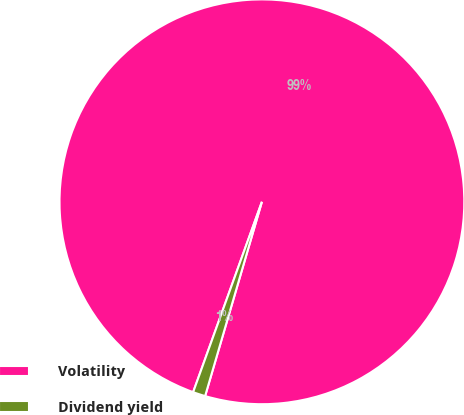Convert chart to OTSL. <chart><loc_0><loc_0><loc_500><loc_500><pie_chart><fcel>Volatility<fcel>Dividend yield<nl><fcel>99.01%<fcel>0.99%<nl></chart> 